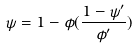<formula> <loc_0><loc_0><loc_500><loc_500>\psi = 1 - \phi ( \frac { 1 - \psi ^ { \prime } } { \phi ^ { \prime } } )</formula> 